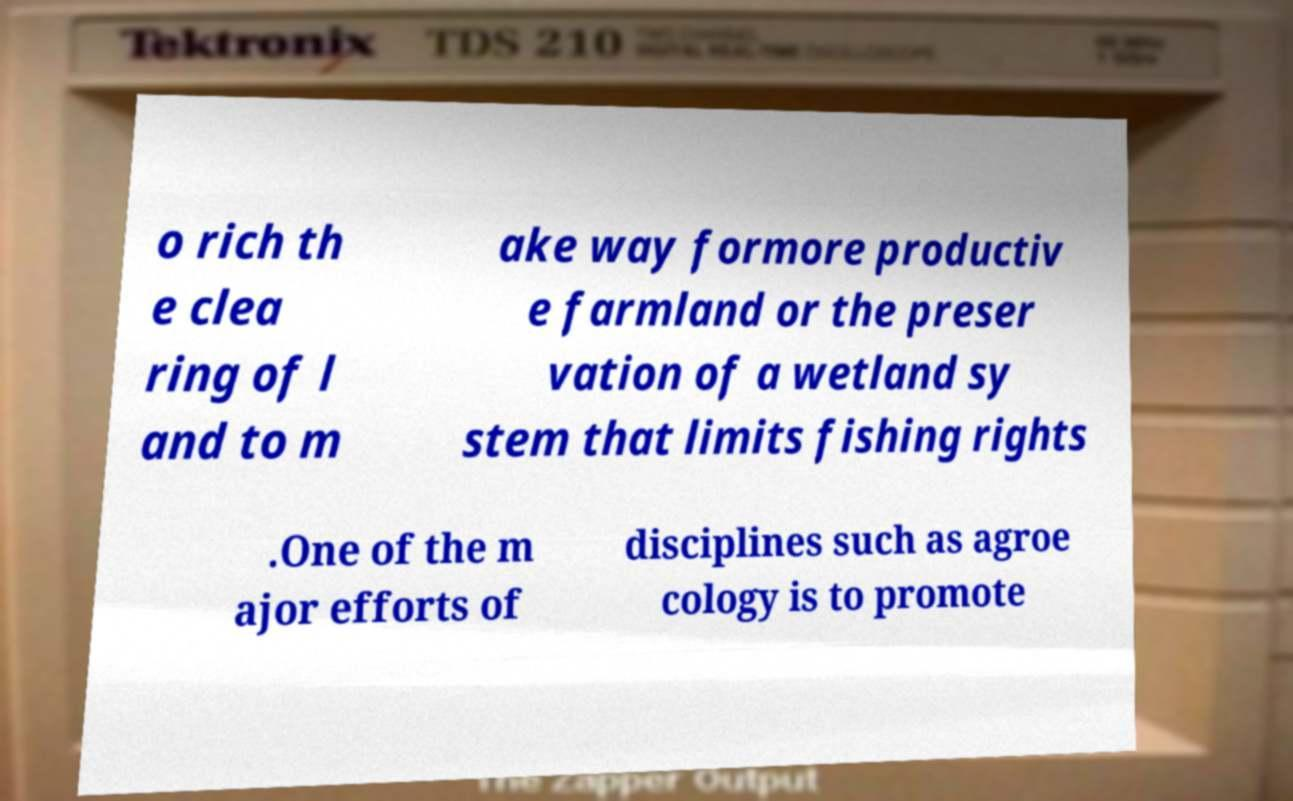For documentation purposes, I need the text within this image transcribed. Could you provide that? o rich th e clea ring of l and to m ake way formore productiv e farmland or the preser vation of a wetland sy stem that limits fishing rights .One of the m ajor efforts of disciplines such as agroe cology is to promote 